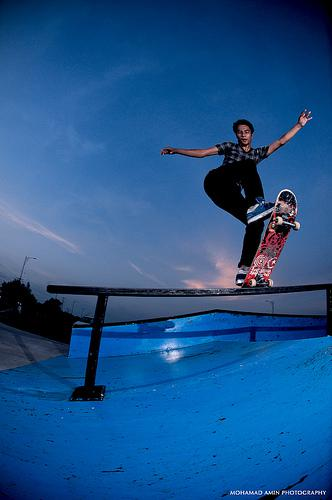Question: who is riding the skateboard?
Choices:
A. The man.
B. A girl.
C. A boy.
D. A woman.
Answer with the letter. Answer: A Question: what is the man doing?
Choices:
A. Skiing.
B. Running.
C. Jumping.
D. Skateboarding.
Answer with the letter. Answer: D Question: where was this photo taken?
Choices:
A. Basketball court.
B. At a skate park.
C. Tennis court.
D. Baseball field.
Answer with the letter. Answer: B Question: what time of day was this picture taken?
Choices:
A. Dawn.
B. Evening.
C. Dusk.
D. Morning.
Answer with the letter. Answer: C 